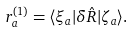<formula> <loc_0><loc_0><loc_500><loc_500>r ^ { ( 1 ) } _ { a } = \langle \xi _ { a } | \delta \hat { R } | \zeta _ { a } \rangle .</formula> 